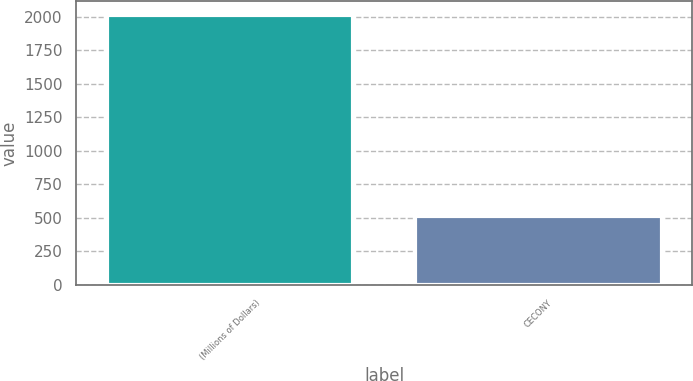<chart> <loc_0><loc_0><loc_500><loc_500><bar_chart><fcel>(Millions of Dollars)<fcel>CECONY<nl><fcel>2013<fcel>516<nl></chart> 